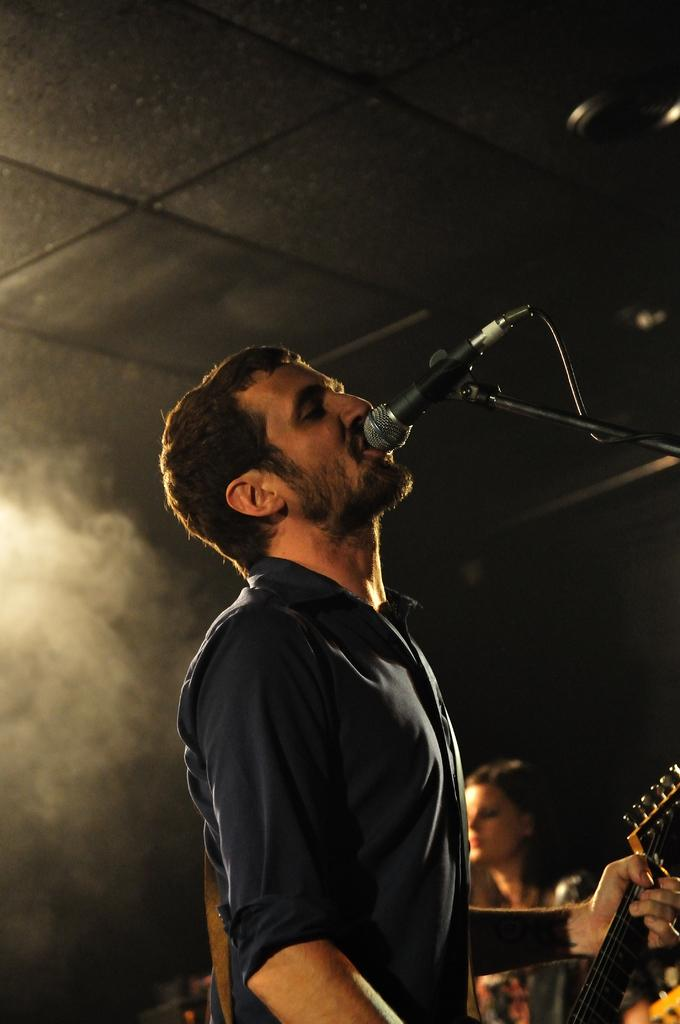Who is the main subject in the image? There is a man in the image. What is the man holding in the image? The man is holding a guitar. What is the man doing with the guitar? The man is singing a song. What object is present to amplify the man's voice? There is a microphone in the image. What type of lettuce can be seen in the image? There is no lettuce present in the image. How does the man's performance taste in the image? The image does not convey the taste of the man's performance, as it is a visual medium. 